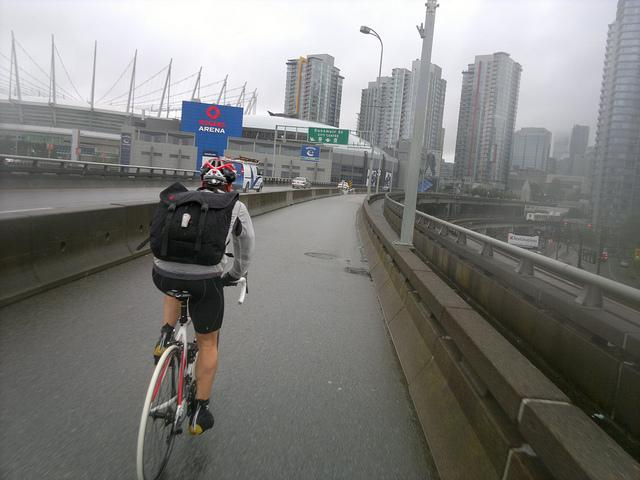What vehicles are allowed on the rightmost lane? Please explain your reasoning. bicycles. A person is riding a bike in the farthest lane to the right. bike lanes are often on the right side of streets. 